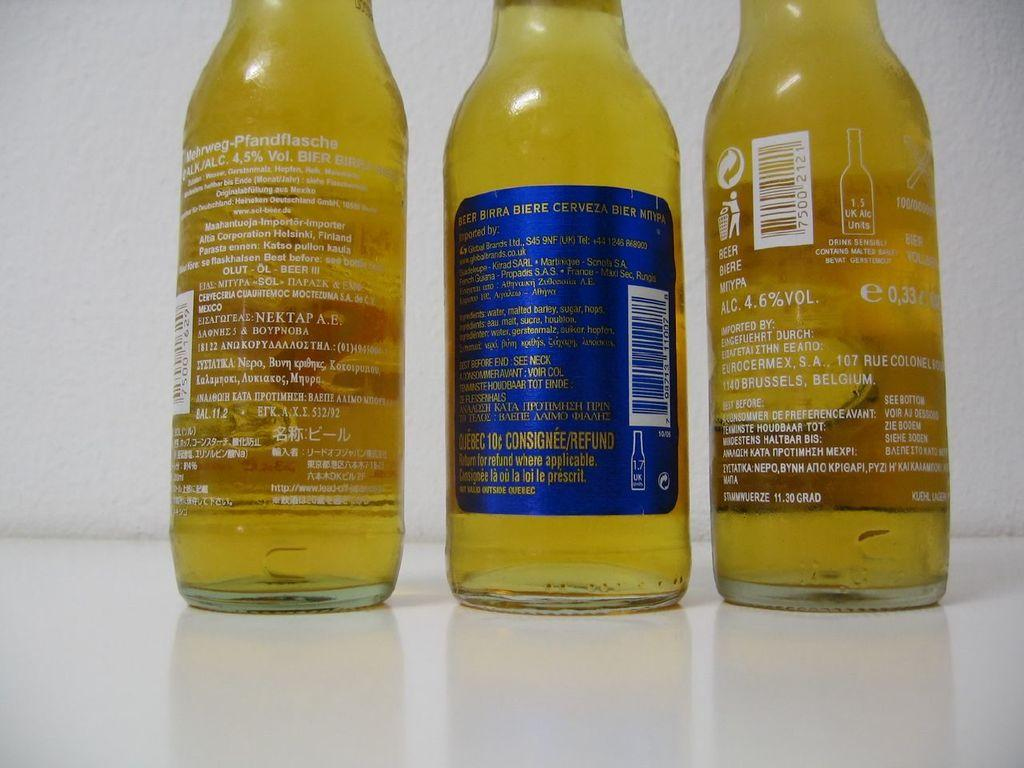How many bottles are visible in the image? There are three bottles in the image. What color are the bottles? The bottles are yellow in color. What type of beef is being smashed by the sun in the image? There is no beef or sun present in the image; it only features three yellow bottles. 